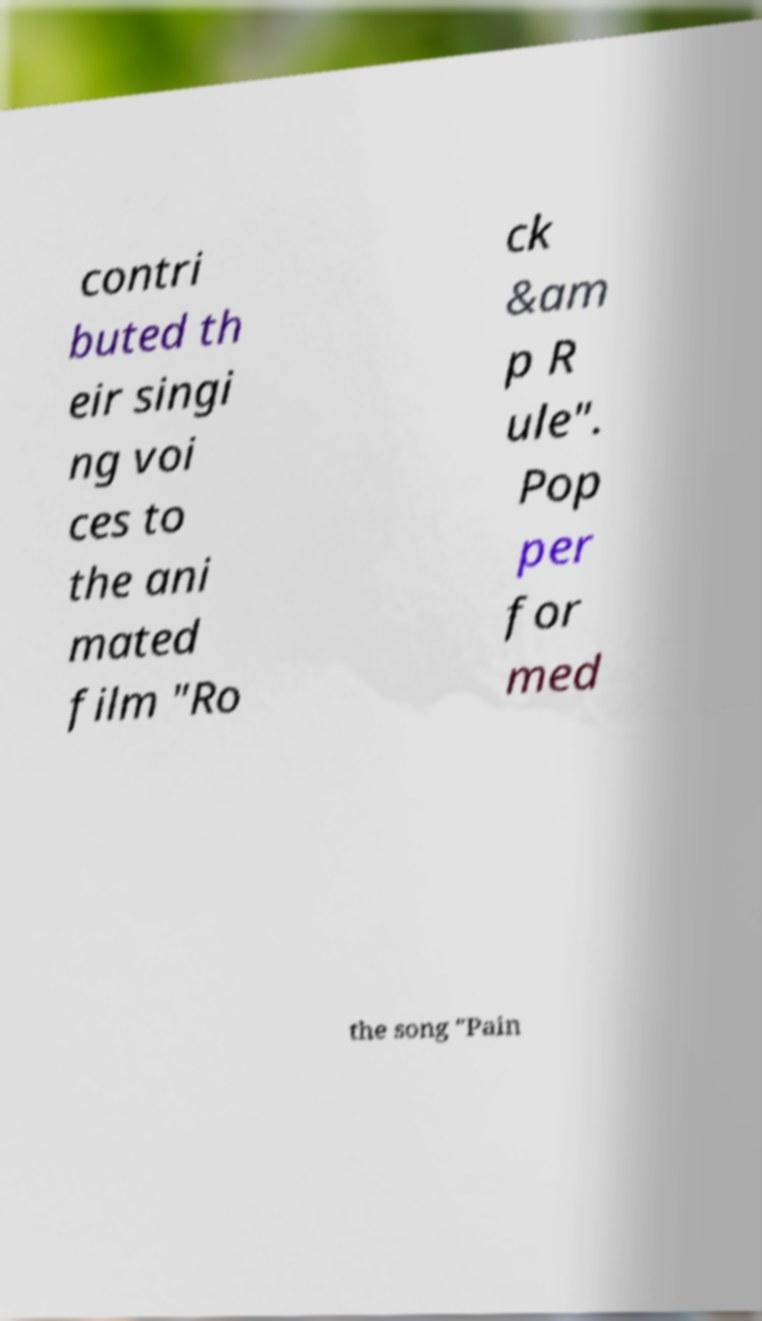Can you read and provide the text displayed in the image?This photo seems to have some interesting text. Can you extract and type it out for me? contri buted th eir singi ng voi ces to the ani mated film "Ro ck &am p R ule". Pop per for med the song "Pain 